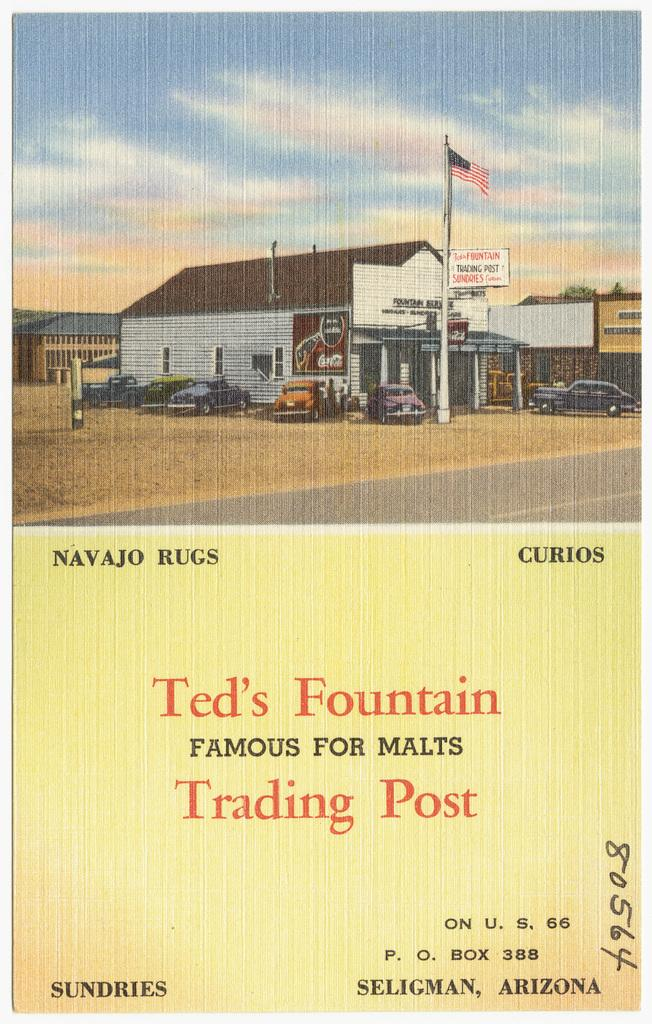<image>
Relay a brief, clear account of the picture shown. An old advertisement shows a picture of Ted's Fountain Trading Post in Seligman, Arizona. 